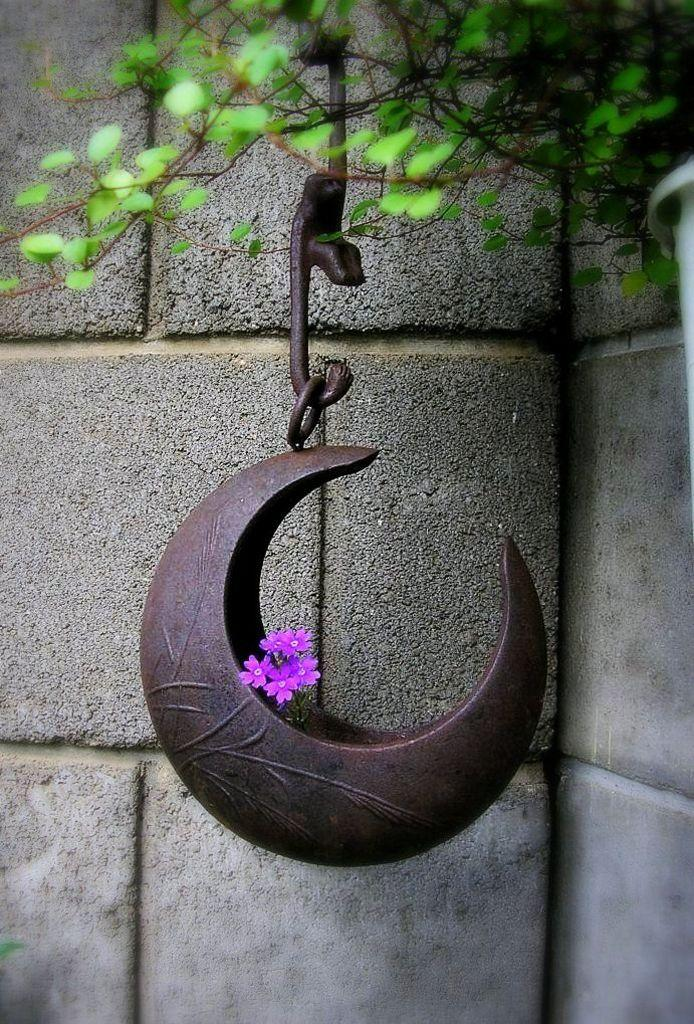What type of object is made of iron in the image? There is an iron object in the image, but its specific type cannot be determined from the provided facts. What type of flora is present in the image? There are flowers and leaves in the image. What can be seen in the background of the image? There is a wall in the background of the image. What type of prose is being recited by the geese in the image? There are no geese present in the image, and therefore no prose can be recited by them. What type of agreement is being discussed by the flowers in the image? There are no flowers or discussions about agreements in the image. 